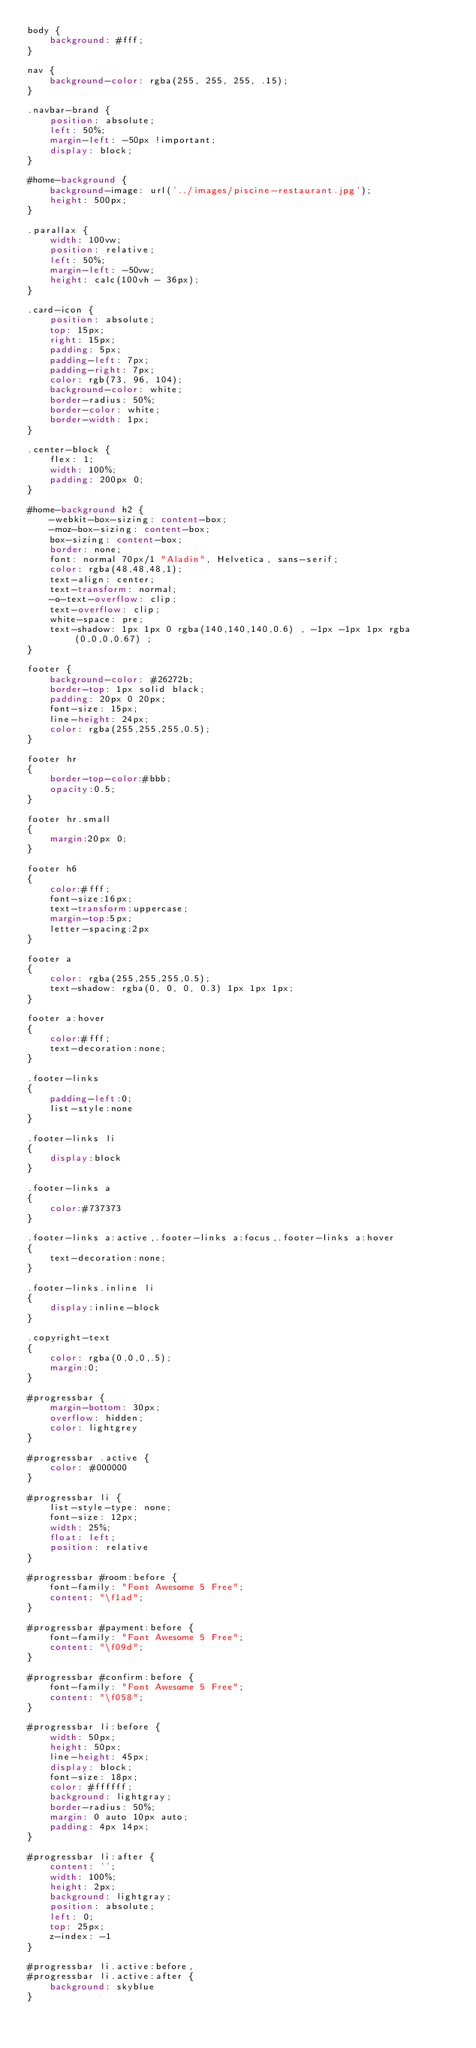Convert code to text. <code><loc_0><loc_0><loc_500><loc_500><_CSS_>body {
    background: #fff;
}

nav {
    background-color: rgba(255, 255, 255, .15);
}

.navbar-brand {
    position: absolute;
    left: 50%;
    margin-left: -50px !important;
    display: block;
}

#home-background {
    background-image: url('../images/piscine-restaurant.jpg');
    height: 500px;
}

.parallax {
    width: 100vw;
    position: relative;
    left: 50%;
    margin-left: -50vw;
    height: calc(100vh - 36px);
}

.card-icon {
    position: absolute;
    top: 15px;
    right: 15px;
    padding: 5px;
    padding-left: 7px;
    padding-right: 7px;
    color: rgb(73, 96, 104);
    background-color: white;
    border-radius: 50%;
    border-color: white;
    border-width: 1px;
}

.center-block {
    flex: 1;
    width: 100%;
    padding: 200px 0;
}

#home-background h2 {
    -webkit-box-sizing: content-box;
    -moz-box-sizing: content-box;
    box-sizing: content-box;
    border: none;
    font: normal 70px/1 "Aladin", Helvetica, sans-serif;
    color: rgba(48,48,48,1);
    text-align: center;
    text-transform: normal;
    -o-text-overflow: clip;
    text-overflow: clip;
    white-space: pre;
    text-shadow: 1px 1px 0 rgba(140,140,140,0.6) , -1px -1px 1px rgba(0,0,0,0.67) ;
}

footer {
    background-color: #26272b;
    border-top: 1px solid black;
    padding: 20px 0 20px;
    font-size: 15px;
    line-height: 24px;
    color: rgba(255,255,255,0.5);
}

footer hr
{
    border-top-color:#bbb;
    opacity:0.5;
}

footer hr.small
{
    margin:20px 0;
}

footer h6
{
    color:#fff;
    font-size:16px;
    text-transform:uppercase;
    margin-top:5px;
    letter-spacing:2px
}

footer a
{
    color: rgba(255,255,255,0.5);
    text-shadow: rgba(0, 0, 0, 0.3) 1px 1px 1px;
}

footer a:hover
{
    color:#fff;
    text-decoration:none;
}

.footer-links
{
    padding-left:0;
    list-style:none
}

.footer-links li
{
    display:block
}

.footer-links a
{
    color:#737373
}

.footer-links a:active,.footer-links a:focus,.footer-links a:hover
{
    text-decoration:none;
}

.footer-links.inline li
{
    display:inline-block
}

.copyright-text
{
    color: rgba(0,0,0,.5);
    margin:0;
}

#progressbar {
    margin-bottom: 30px;
    overflow: hidden;
    color: lightgrey
}

#progressbar .active {
    color: #000000
}

#progressbar li {
    list-style-type: none;
    font-size: 12px;
    width: 25%;
    float: left;
    position: relative
}

#progressbar #room:before {
    font-family: "Font Awesome 5 Free";
    content: "\f1ad";
}

#progressbar #payment:before {
    font-family: "Font Awesome 5 Free";
    content: "\f09d";
}

#progressbar #confirm:before {
    font-family: "Font Awesome 5 Free";
    content: "\f058";
}

#progressbar li:before {
    width: 50px;
    height: 50px;
    line-height: 45px;
    display: block;
    font-size: 18px;
    color: #ffffff;
    background: lightgray;
    border-radius: 50%;
    margin: 0 auto 10px auto;
    padding: 4px 14px;
}

#progressbar li:after {
    content: '';
    width: 100%;
    height: 2px;
    background: lightgray;
    position: absolute;
    left: 0;
    top: 25px;
    z-index: -1
}

#progressbar li.active:before,
#progressbar li.active:after {
    background: skyblue
}</code> 